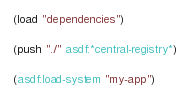Convert code to text. <code><loc_0><loc_0><loc_500><loc_500><_Lisp_>(load "dependencies")

(push "./" asdf:*central-registry*)

(asdf:load-system "my-app")

</code> 